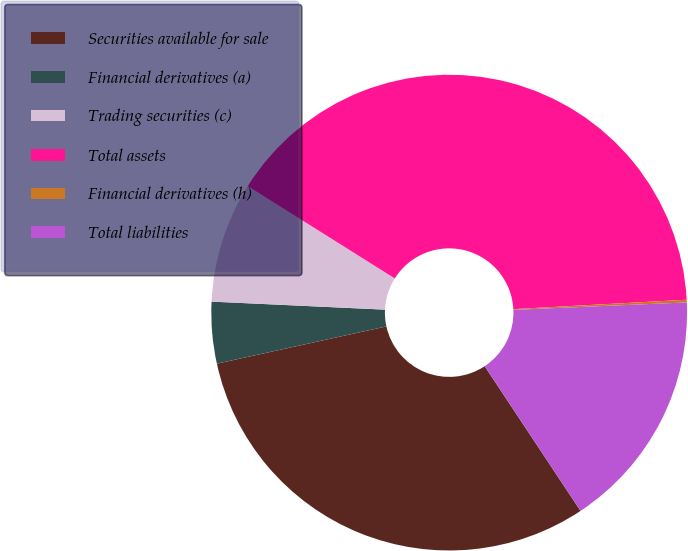Convert chart. <chart><loc_0><loc_0><loc_500><loc_500><pie_chart><fcel>Securities available for sale<fcel>Financial derivatives (a)<fcel>Trading securities (c)<fcel>Total assets<fcel>Financial derivatives (h)<fcel>Total liabilities<nl><fcel>30.87%<fcel>4.18%<fcel>8.19%<fcel>40.21%<fcel>0.18%<fcel>16.37%<nl></chart> 